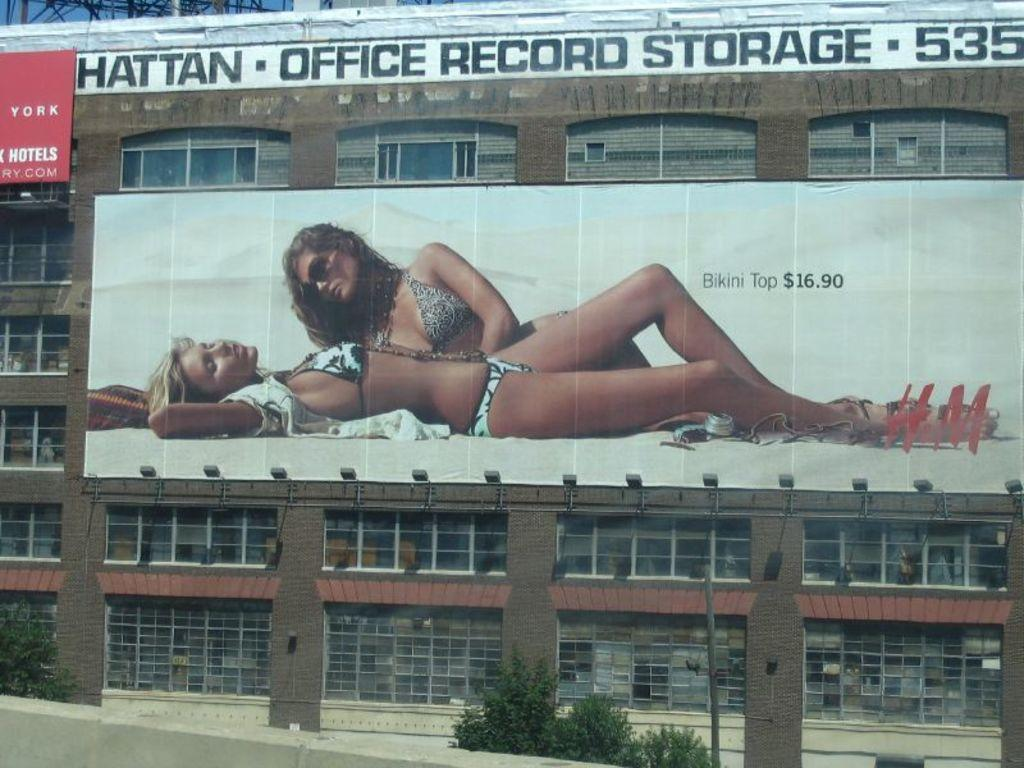Provide a one-sentence caption for the provided image. a billboard for H&M showing bikini top priced at $16.90. 